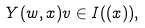Convert formula to latex. <formula><loc_0><loc_0><loc_500><loc_500>Y ( w , x ) v \in I ( ( x ) ) ,</formula> 